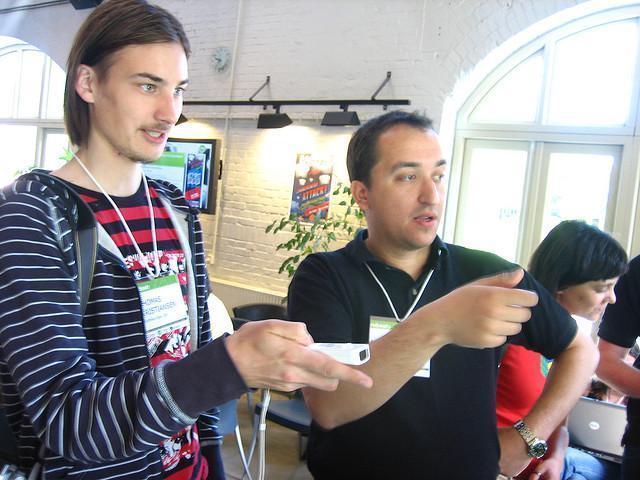How many people are there?
Give a very brief answer. 4. How many people can you see?
Give a very brief answer. 4. How many boats are in the photo?
Give a very brief answer. 0. 